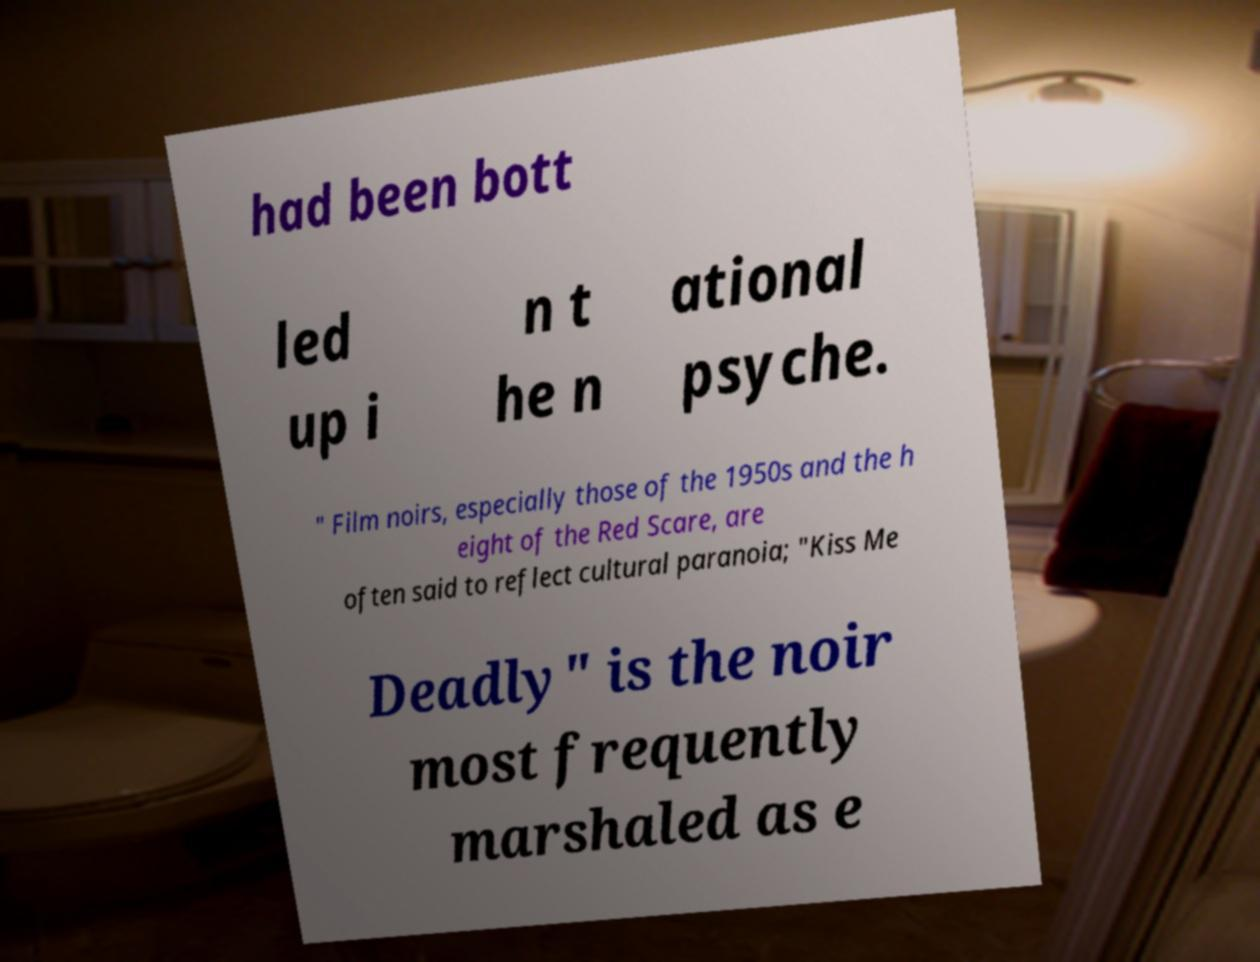Can you accurately transcribe the text from the provided image for me? had been bott led up i n t he n ational psyche. " Film noirs, especially those of the 1950s and the h eight of the Red Scare, are often said to reflect cultural paranoia; "Kiss Me Deadly" is the noir most frequently marshaled as e 